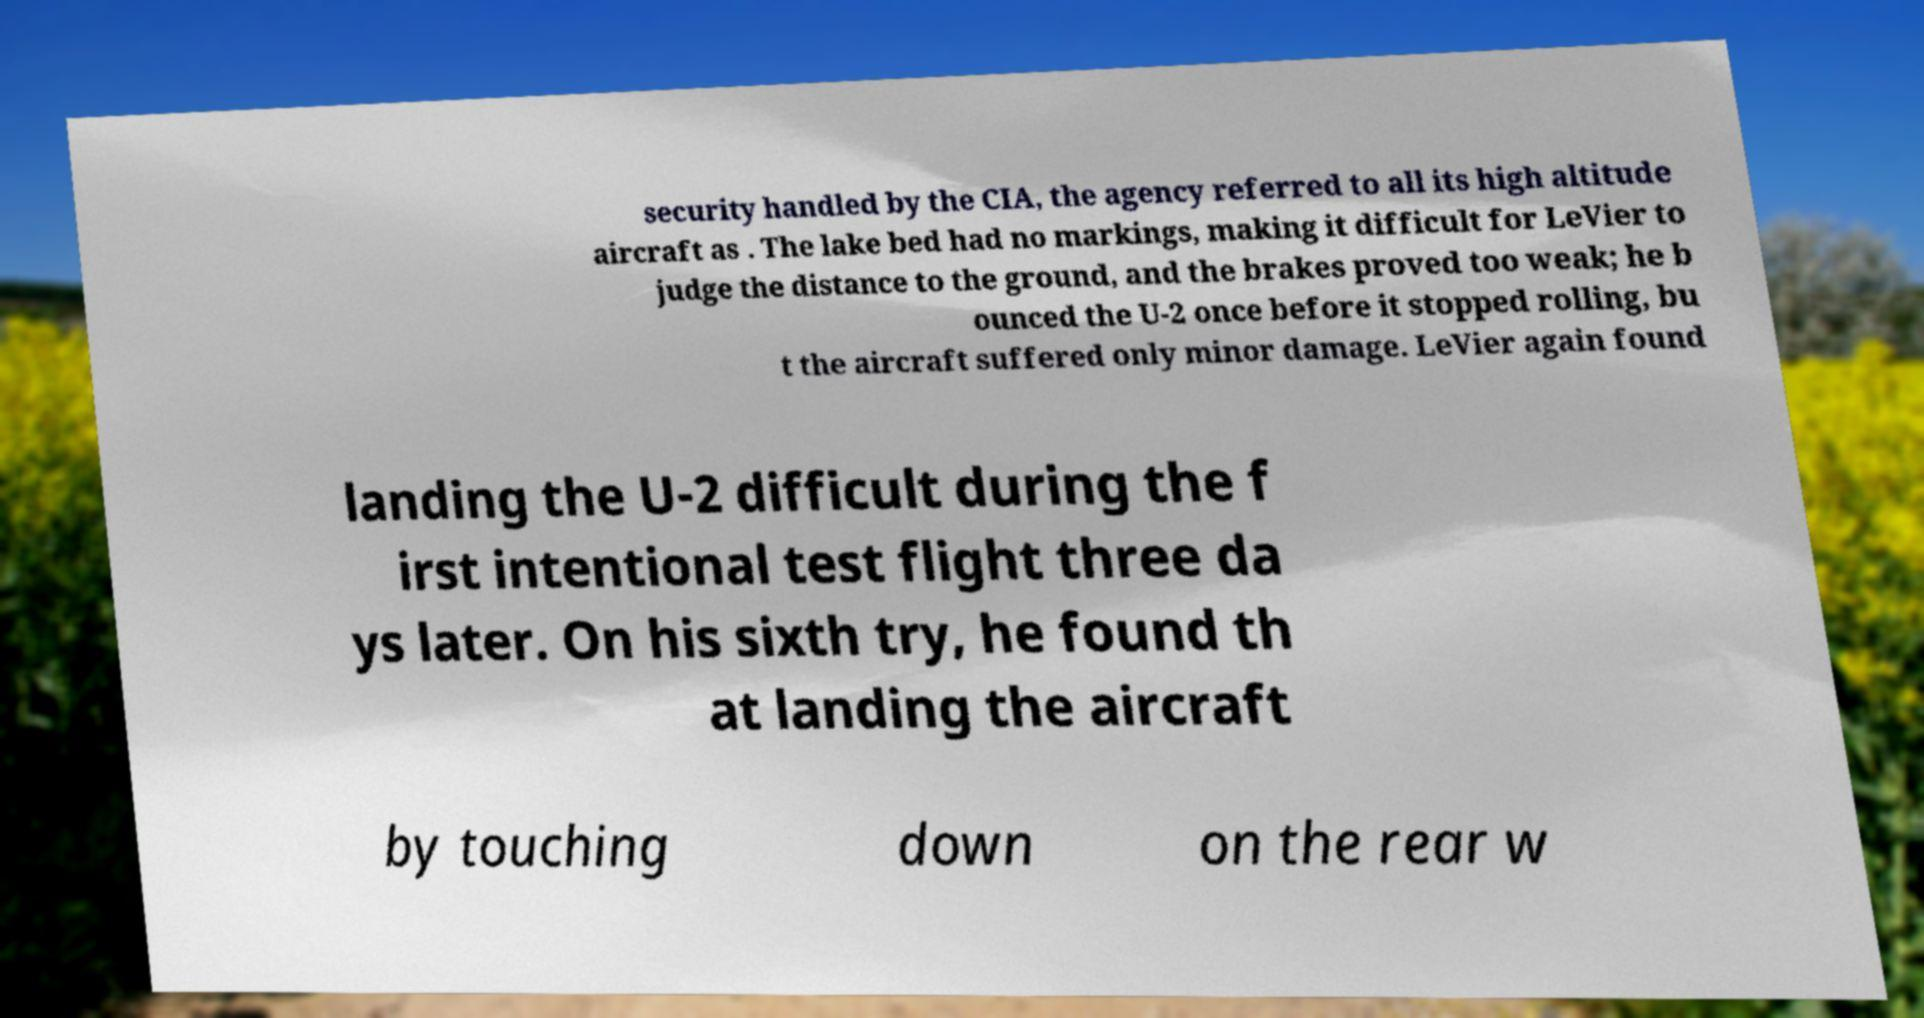Please identify and transcribe the text found in this image. security handled by the CIA, the agency referred to all its high altitude aircraft as . The lake bed had no markings, making it difficult for LeVier to judge the distance to the ground, and the brakes proved too weak; he b ounced the U-2 once before it stopped rolling, bu t the aircraft suffered only minor damage. LeVier again found landing the U-2 difficult during the f irst intentional test flight three da ys later. On his sixth try, he found th at landing the aircraft by touching down on the rear w 